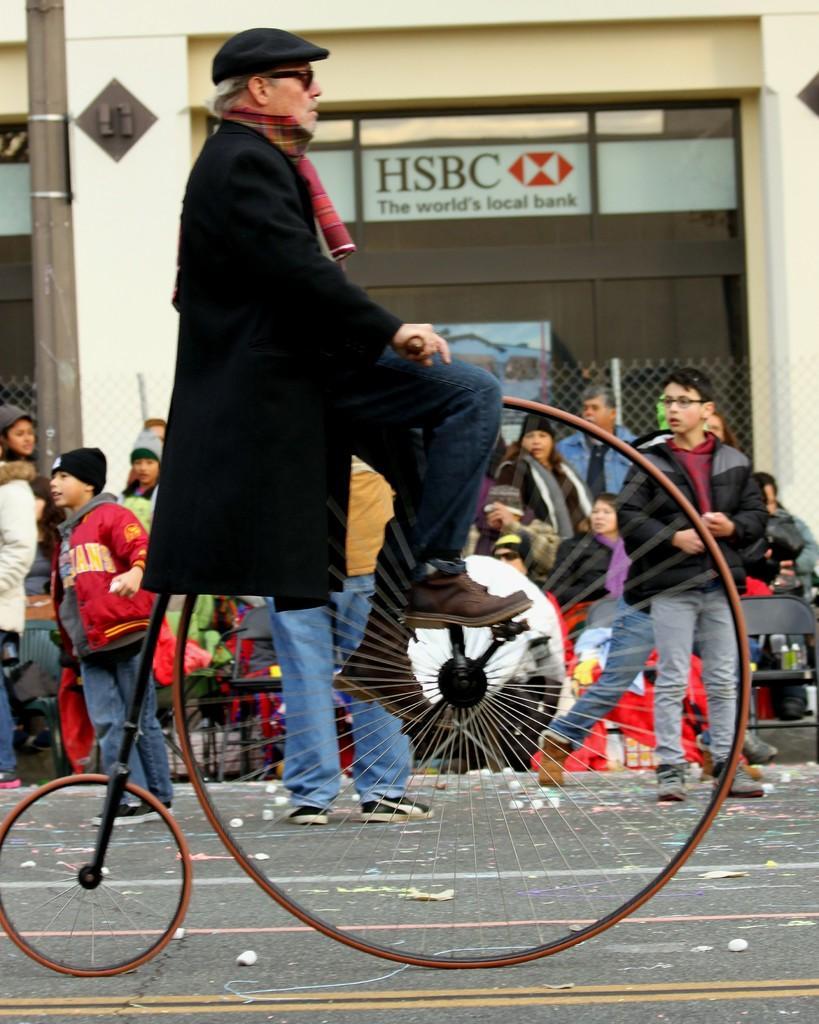Can you describe this image briefly? There is a man riding a vehicle. This is wheel and here we can see some persons are standing on the road. In the background there is a building. And this is pole and there is a board. 